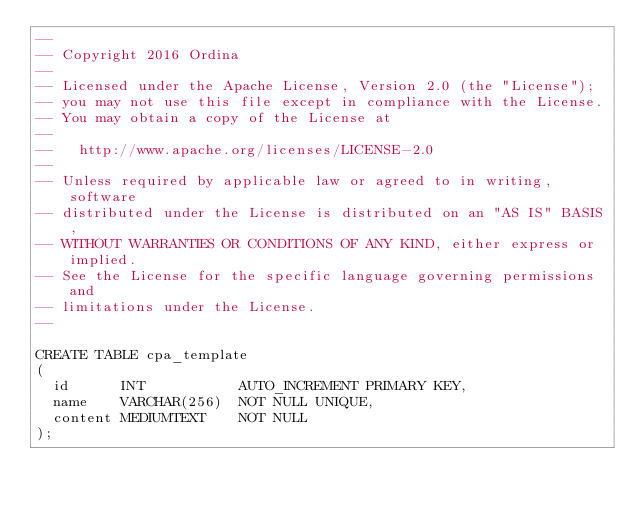<code> <loc_0><loc_0><loc_500><loc_500><_SQL_>--
-- Copyright 2016 Ordina
--
-- Licensed under the Apache License, Version 2.0 (the "License");
-- you may not use this file except in compliance with the License.
-- You may obtain a copy of the License at
--
--   http://www.apache.org/licenses/LICENSE-2.0
--
-- Unless required by applicable law or agreed to in writing, software
-- distributed under the License is distributed on an "AS IS" BASIS,
-- WITHOUT WARRANTIES OR CONDITIONS OF ANY KIND, either express or implied.
-- See the License for the specific language governing permissions and
-- limitations under the License.
--

CREATE TABLE cpa_template
(
	id			INT						AUTO_INCREMENT PRIMARY KEY,
	name		VARCHAR(256)	NOT NULL UNIQUE,
	content	MEDIUMTEXT		NOT NULL
);
</code> 